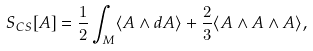<formula> <loc_0><loc_0><loc_500><loc_500>S _ { C S } [ A ] = \frac { 1 } { 2 } \int _ { M } \langle A \wedge d A \rangle + \frac { 2 } { 3 } \langle A \wedge A \wedge A \rangle ,</formula> 